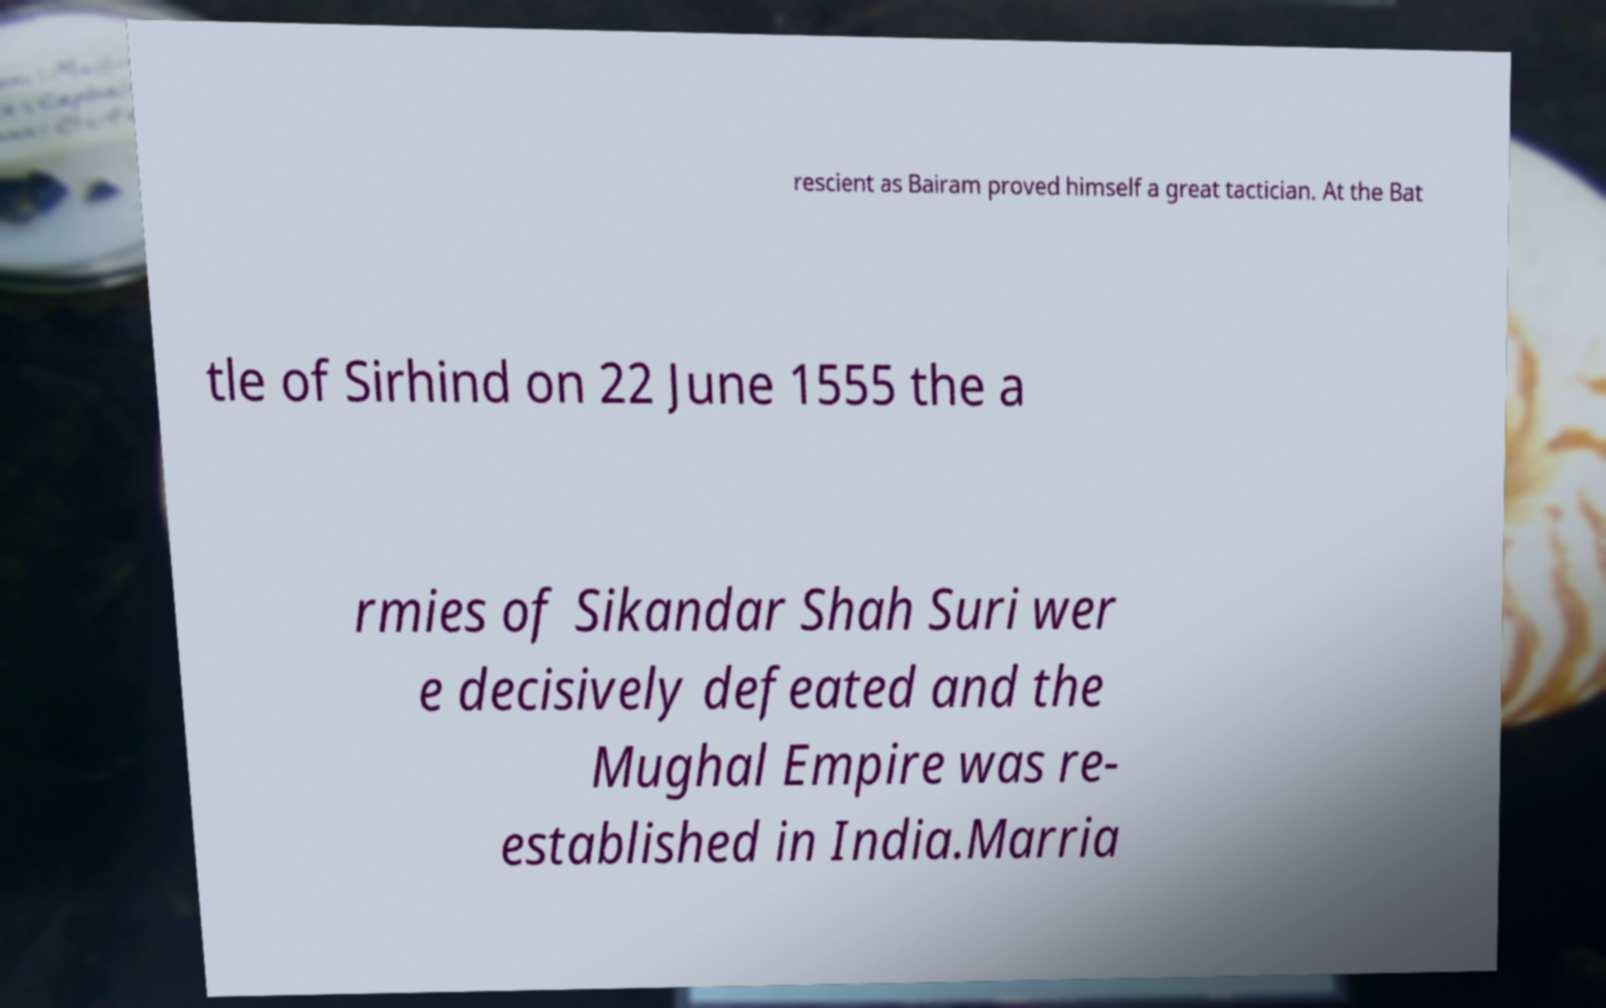There's text embedded in this image that I need extracted. Can you transcribe it verbatim? rescient as Bairam proved himself a great tactician. At the Bat tle of Sirhind on 22 June 1555 the a rmies of Sikandar Shah Suri wer e decisively defeated and the Mughal Empire was re- established in India.Marria 